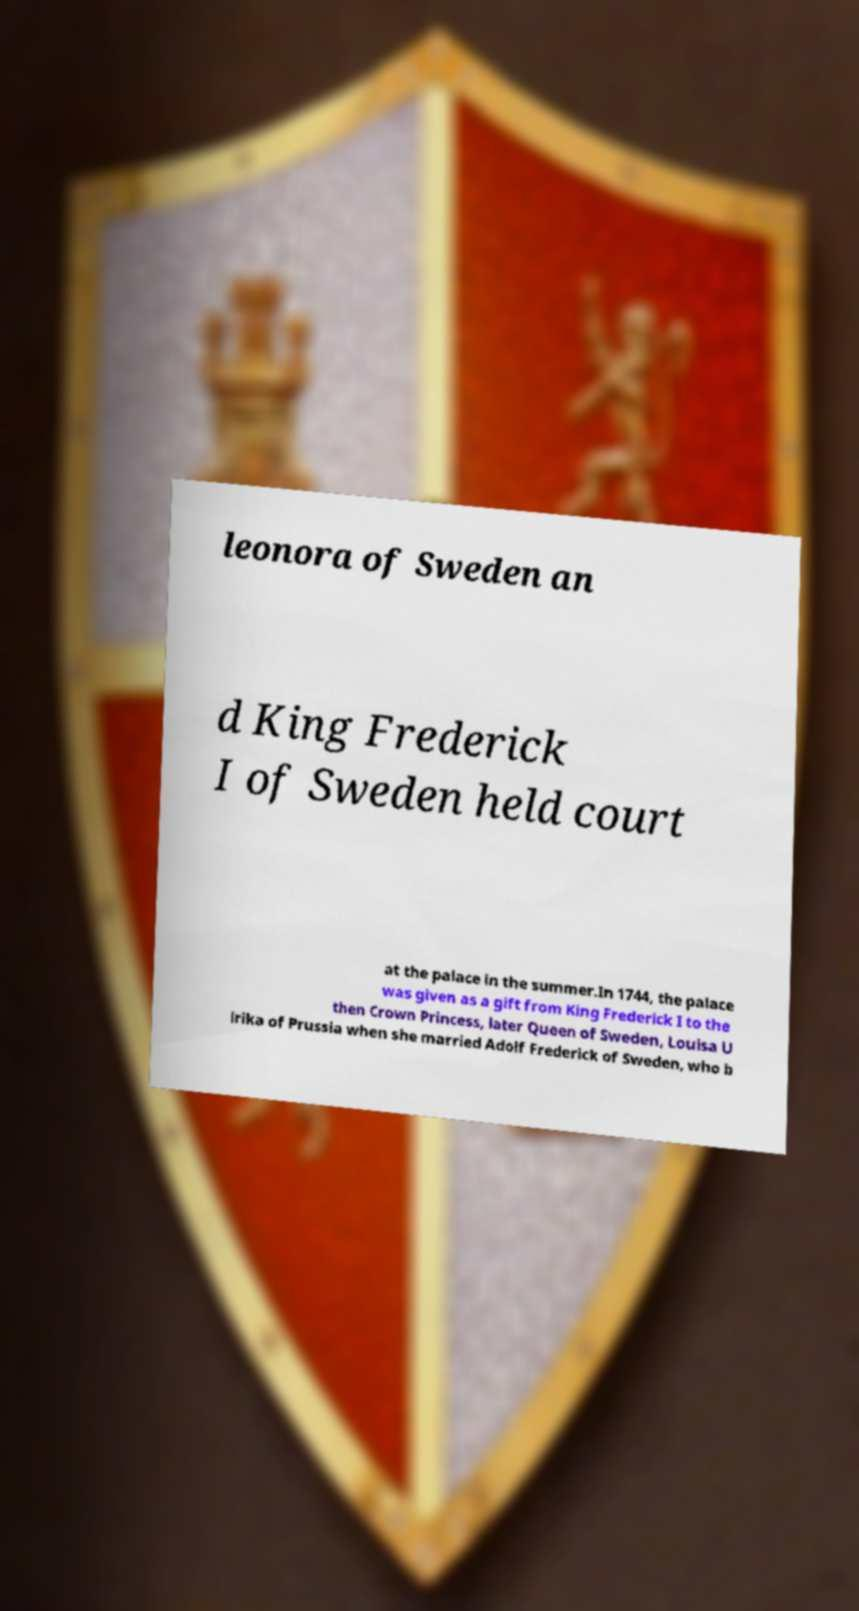I need the written content from this picture converted into text. Can you do that? leonora of Sweden an d King Frederick I of Sweden held court at the palace in the summer.In 1744, the palace was given as a gift from King Frederick I to the then Crown Princess, later Queen of Sweden, Louisa U lrika of Prussia when she married Adolf Frederick of Sweden, who b 